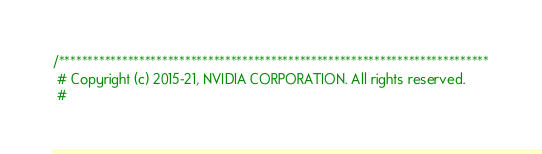<code> <loc_0><loc_0><loc_500><loc_500><_C++_>/***************************************************************************
 # Copyright (c) 2015-21, NVIDIA CORPORATION. All rights reserved.
 #</code> 